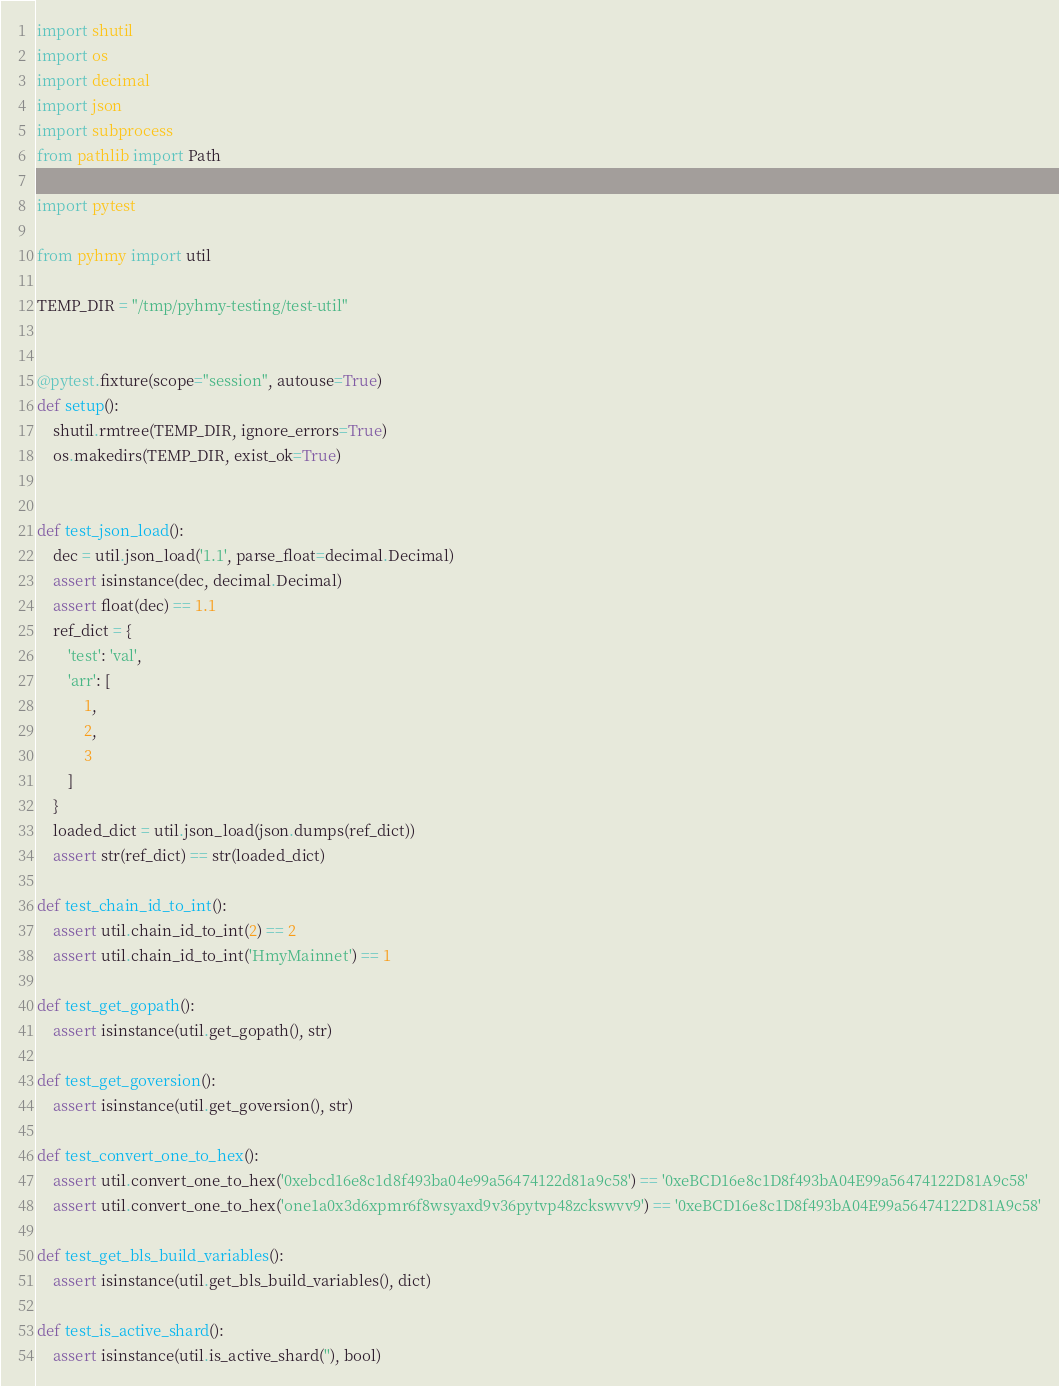<code> <loc_0><loc_0><loc_500><loc_500><_Python_>import shutil
import os
import decimal
import json
import subprocess
from pathlib import Path

import pytest

from pyhmy import util

TEMP_DIR = "/tmp/pyhmy-testing/test-util"


@pytest.fixture(scope="session", autouse=True)
def setup():
    shutil.rmtree(TEMP_DIR, ignore_errors=True)
    os.makedirs(TEMP_DIR, exist_ok=True)


def test_json_load():
    dec = util.json_load('1.1', parse_float=decimal.Decimal)
    assert isinstance(dec, decimal.Decimal)
    assert float(dec) == 1.1
    ref_dict = {
        'test': 'val',
        'arr': [
            1,
            2,
            3
        ]
    }
    loaded_dict = util.json_load(json.dumps(ref_dict))
    assert str(ref_dict) == str(loaded_dict)

def test_chain_id_to_int():
    assert util.chain_id_to_int(2) == 2
    assert util.chain_id_to_int('HmyMainnet') == 1

def test_get_gopath():
    assert isinstance(util.get_gopath(), str)

def test_get_goversion():
    assert isinstance(util.get_goversion(), str)

def test_convert_one_to_hex():
    assert util.convert_one_to_hex('0xebcd16e8c1d8f493ba04e99a56474122d81a9c58') == '0xeBCD16e8c1D8f493bA04E99a56474122D81A9c58'
    assert util.convert_one_to_hex('one1a0x3d6xpmr6f8wsyaxd9v36pytvp48zckswvv9') == '0xeBCD16e8c1D8f493bA04E99a56474122D81A9c58'

def test_get_bls_build_variables():
    assert isinstance(util.get_bls_build_variables(), dict)

def test_is_active_shard():
    assert isinstance(util.is_active_shard(''), bool)
</code> 